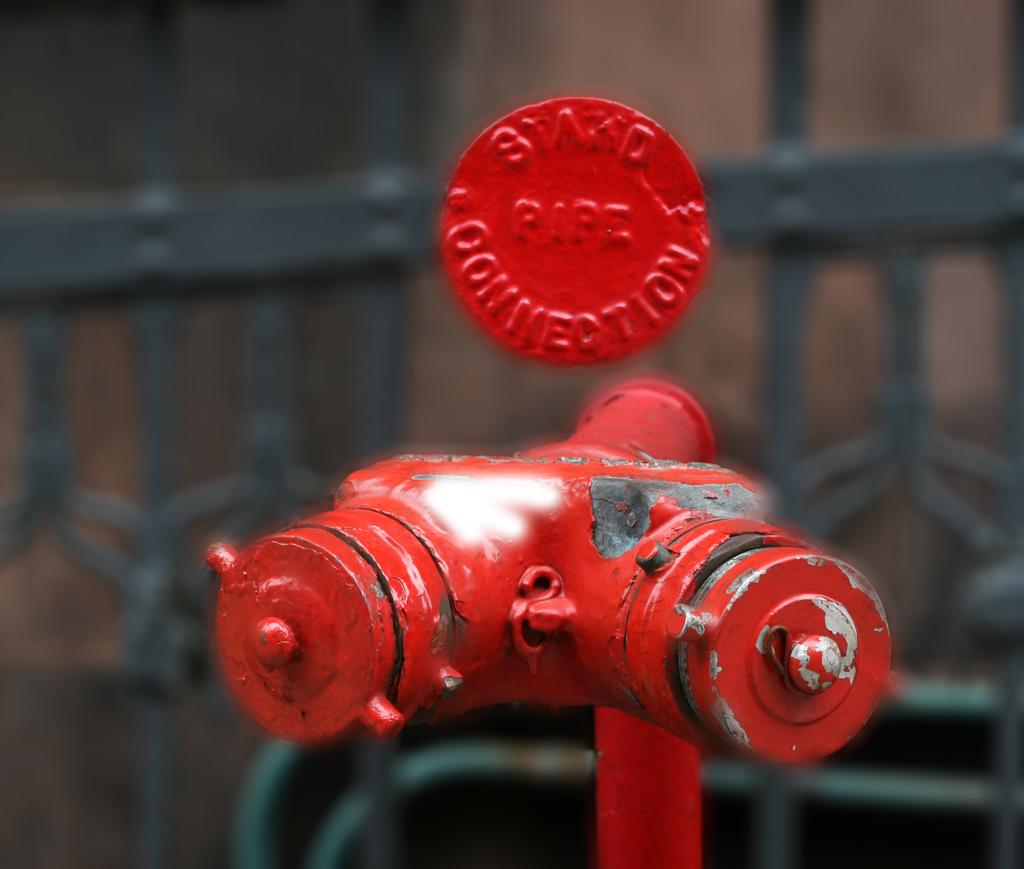What is the main object in the image? There is a fire hydrant stand in the image. What color is the fire hydrant stand? The fire hydrant stand is red. What can be seen in the background of the image? There is an iron railing in the background of the image. How is the iron railing depicted in the image? The iron railing is blurred in the background. What type of religious symbol can be seen on the fire hydrant stand? There is no religious symbol present on the fire hydrant stand in the image. Can you tell me how many gloves are hanging on the iron railing? There are no gloves present on the iron railing in the image. 